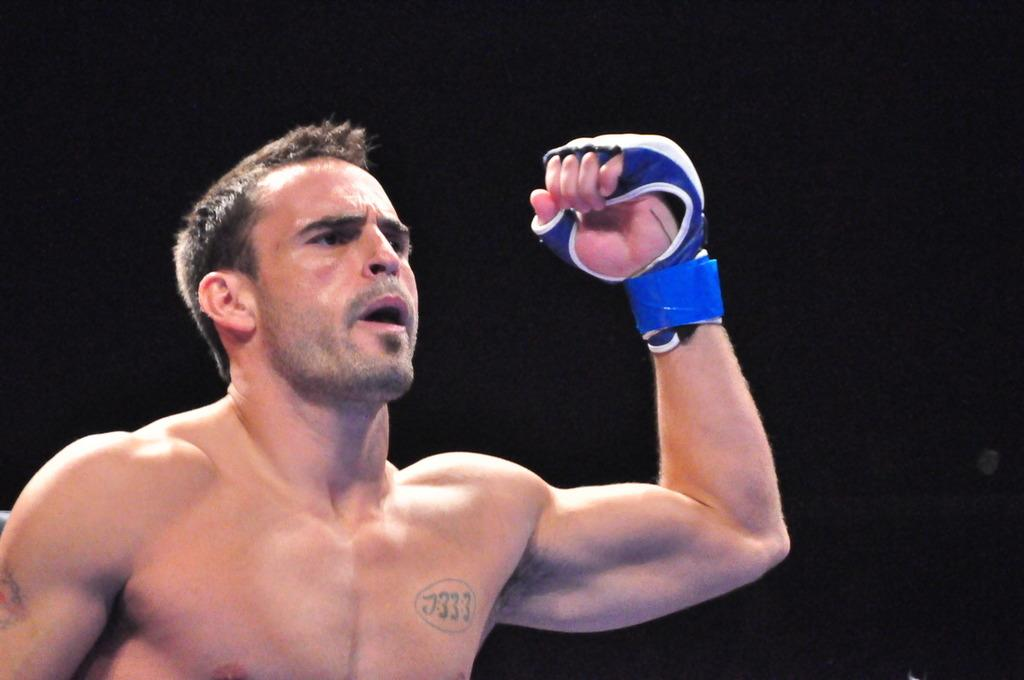Who is present in the image? There is a man in the image. What is the man wearing on his hand? The man is wearing a blue glove. What color is the background of the image? The background of the image is black. What type of bell can be heard ringing in the wilderness in the image? There is no bell or wilderness present in the image; it features a man wearing a blue glove against a black background. 